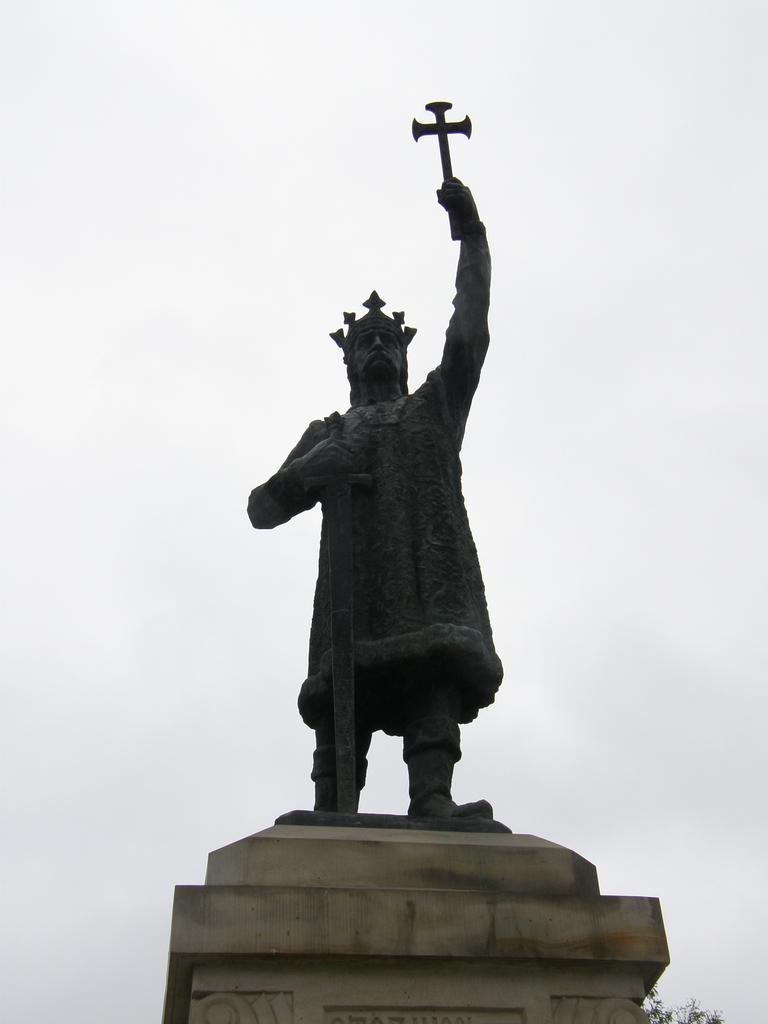In one or two sentences, can you explain what this image depicts? In the image there is a statue of a man with a crown and holding a sword in the hand. And the statue is on the pillar. In the background there is a sky. 